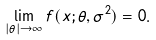Convert formula to latex. <formula><loc_0><loc_0><loc_500><loc_500>\lim _ { | \theta | \to \infty } f ( x ; \theta , \sigma ^ { 2 } ) = 0 .</formula> 